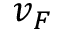Convert formula to latex. <formula><loc_0><loc_0><loc_500><loc_500>v _ { F }</formula> 